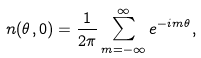<formula> <loc_0><loc_0><loc_500><loc_500>n ( \theta , 0 ) = \frac { 1 } { 2 \pi } \sum _ { m = - \infty } ^ { \infty } e ^ { - i m \theta } ,</formula> 